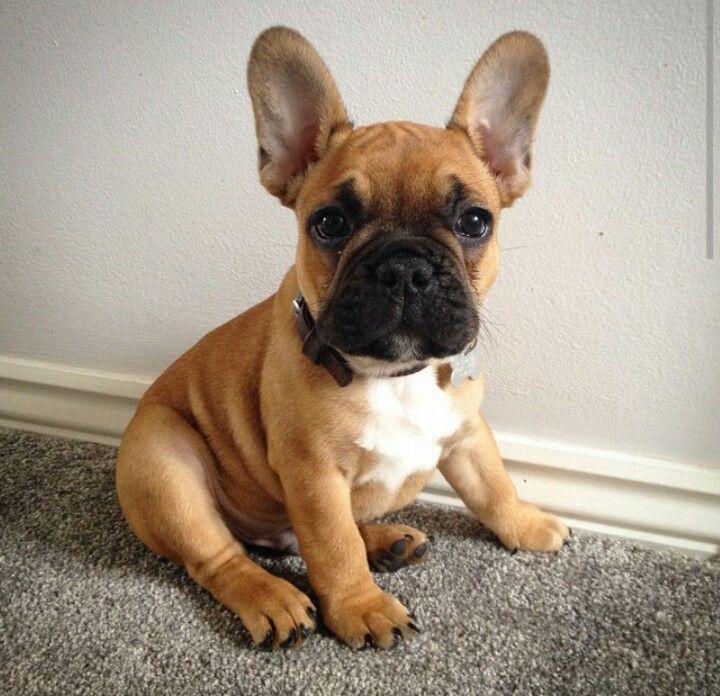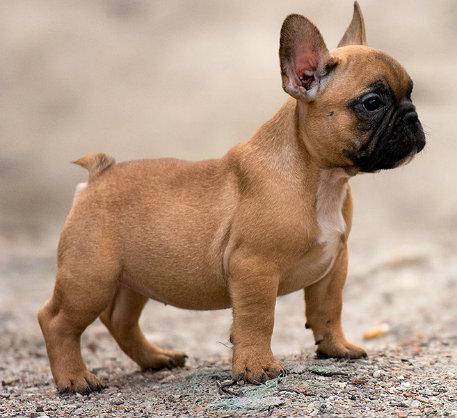The first image is the image on the left, the second image is the image on the right. Given the left and right images, does the statement "There are eight dog legs visible" hold true? Answer yes or no. Yes. 